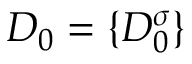Convert formula to latex. <formula><loc_0><loc_0><loc_500><loc_500>D _ { 0 } = \{ D _ { 0 } ^ { \sigma } \}</formula> 